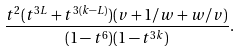Convert formula to latex. <formula><loc_0><loc_0><loc_500><loc_500>\frac { t ^ { 2 } ( t ^ { 3 L } + t ^ { 3 ( k - L ) } ) ( v + 1 / w + w / v ) } { ( 1 - t ^ { 6 } ) ( 1 - t ^ { 3 k } ) } .</formula> 